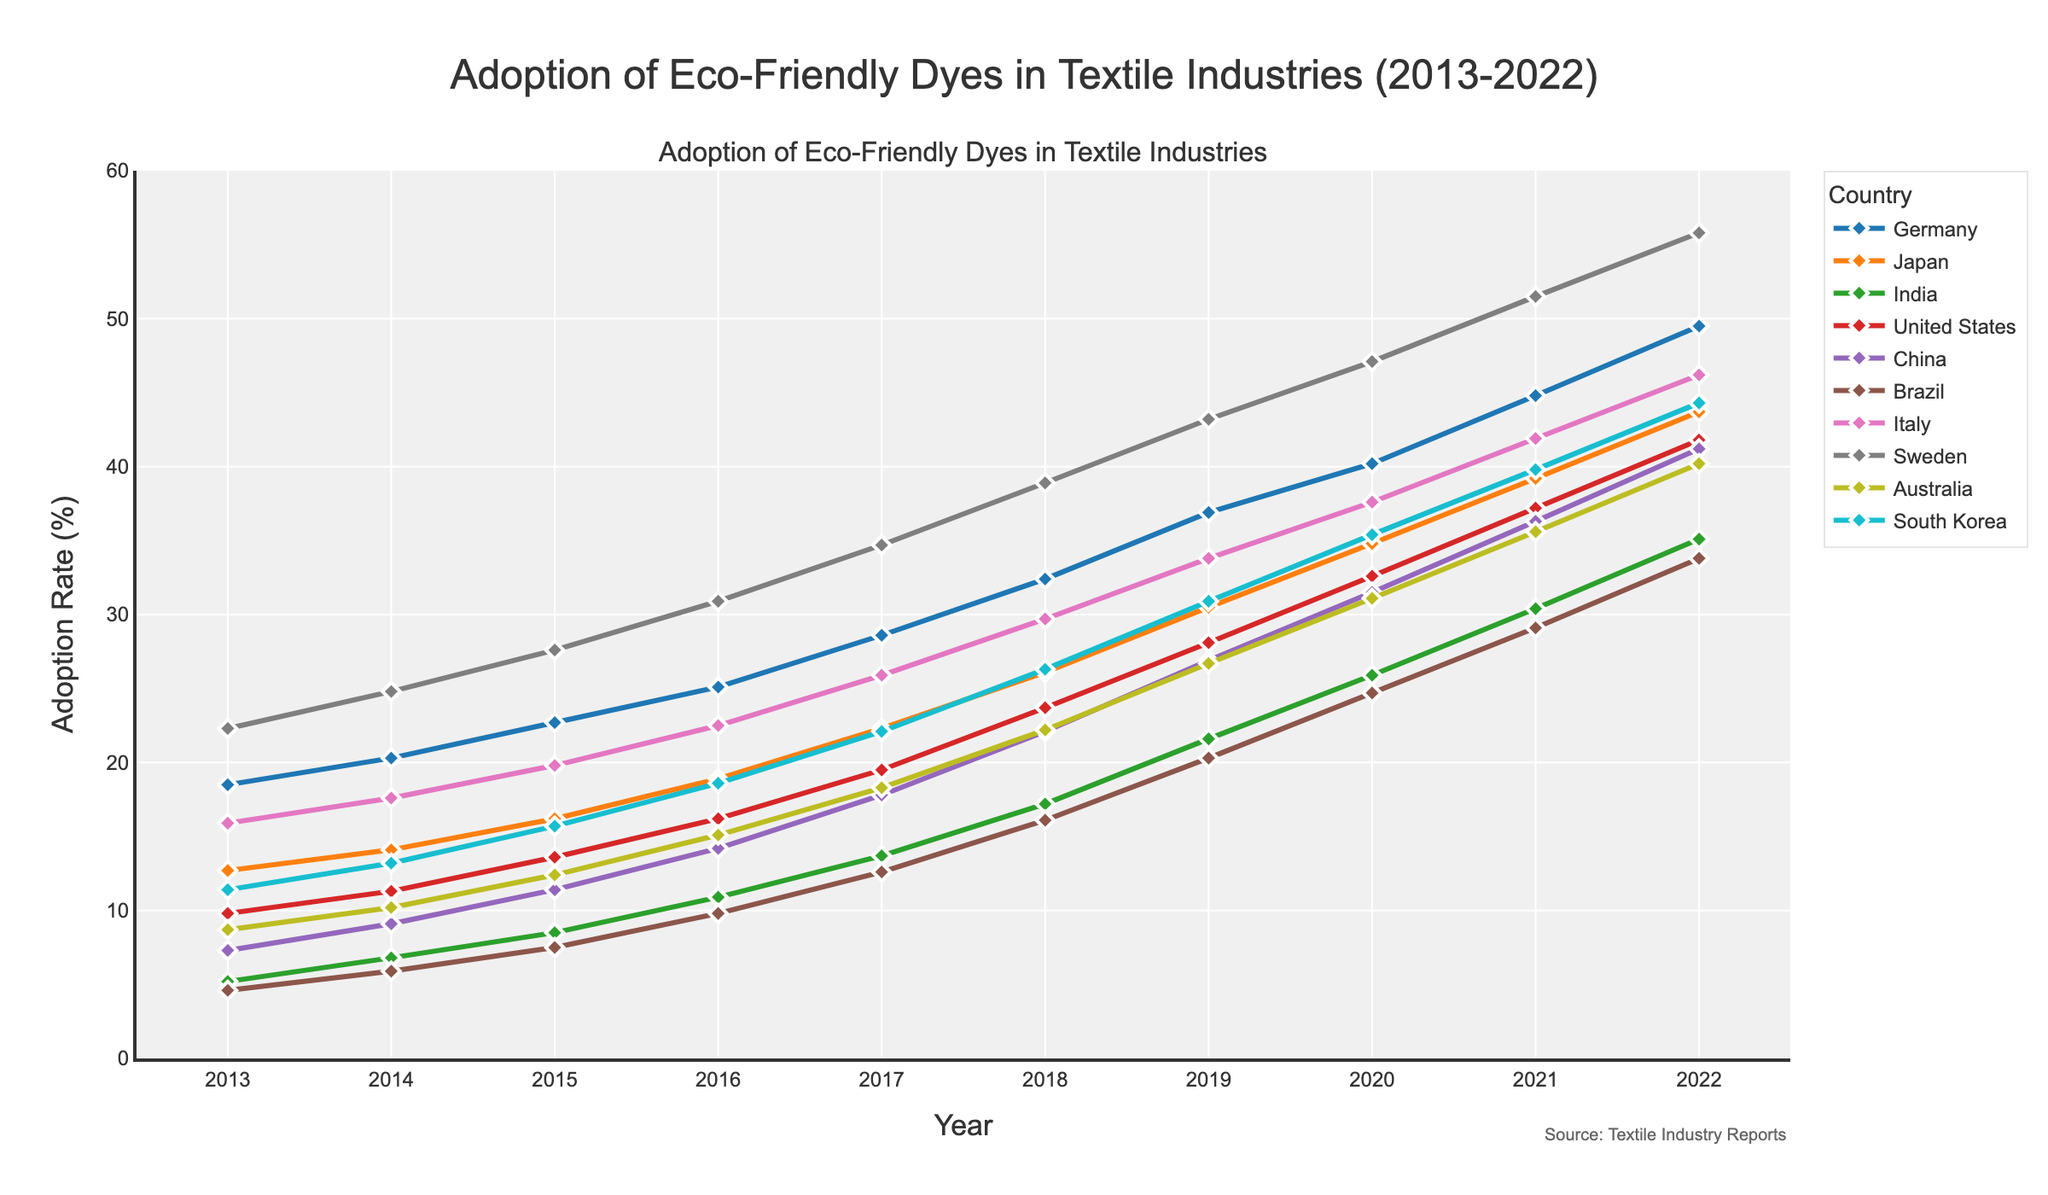What country had the highest adoption rate of eco-friendly dyes in 2022? By looking at the 2022 data points, we see that Sweden has the highest adoption rate.
Answer: Sweden Which country showed the most significant absolute increase in adoption rate from 2013 to 2022? Calculate the difference between the 2022 and 2013 values for each country. Sweden had an increase from 22.3% to 55.8%, which is the largest increase (33.5).
Answer: Sweden Compare the adoption rates of eco-friendly dyes between Germany and Japan in 2020; which country had a higher rate? Germany had an adoption rate of 40.2% in 2020, and Japan had 34.8%. Germany's rate is higher.
Answer: Germany What is the average adoption rate for eco-friendly dyes for Brazil from 2013 to 2022? Sum the adoption rates from 2013 to 2022 and divide by the number of years. (4.6 + 5.9 + 7.5 + 9.8 + 12.6 + 16.1 + 20.3 + 24.7 + 29.1 + 33.8) / 10 = 16.44
Answer: 16.44 Which year did India see its most significant increase in adoption rate compared to the previous year? By comparing the yearly differences, the largest increase for India is from 2016 to 2017 (10.9% to 13.7%), which is 2.8%.
Answer: 2017 In 2021, which countries had an adoption rate greater than 40%? By examining the 2021 data points, Germany (44.8%), Sweden (51.5%), and South Korea (39.8%) had adoption rates greater than 40%.
Answer: Germany, Sweden, South Korea What was the trend in the adoption rate of eco-friendly dyes in China from 2015 to 2017? Examine the data points for China in these years: 2015 (11.4%), 2016 (14.2%), 2017 (17.8%). The trend is an upward increase.
Answer: Upward/Increasing By how much did the United States' adoption rate change between 2019 and 2020? Looking at the figures, the rate in 2019 was 28.1% and in 2020 it was 32.6%. The change is 32.6 - 28.1 = 4.5%.
Answer: 4.5% Of the countries listed, which one had the lowest adoption rate in 2013 and what was it? Brazil had the lowest adoption rate in 2013 at 4.6%.
Answer: Brazil, 4.6% 